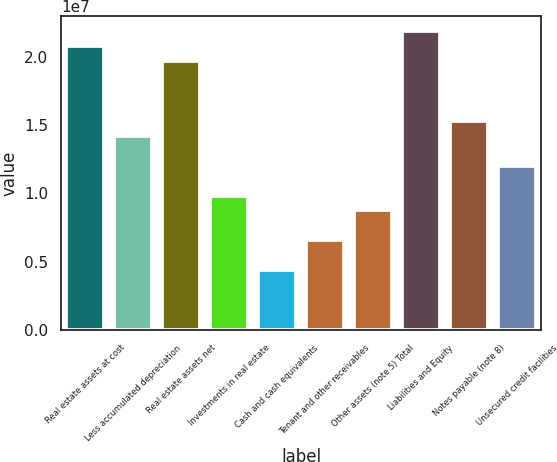<chart> <loc_0><loc_0><loc_500><loc_500><bar_chart><fcel>Real estate assets at cost<fcel>Less accumulated depreciation<fcel>Real estate assets net<fcel>Investments in real estate<fcel>Cash and cash equivalents<fcel>Tenant and other receivables<fcel>Other assets (note 5) Total<fcel>Liabilities and Equity<fcel>Notes payable (note 8)<fcel>Unsecured credit facilities<nl><fcel>2.0794e+07<fcel>1.42278e+07<fcel>1.96997e+07<fcel>9.85029e+06<fcel>4.37842e+06<fcel>6.56717e+06<fcel>8.75592e+06<fcel>2.18884e+07<fcel>1.53222e+07<fcel>1.2039e+07<nl></chart> 